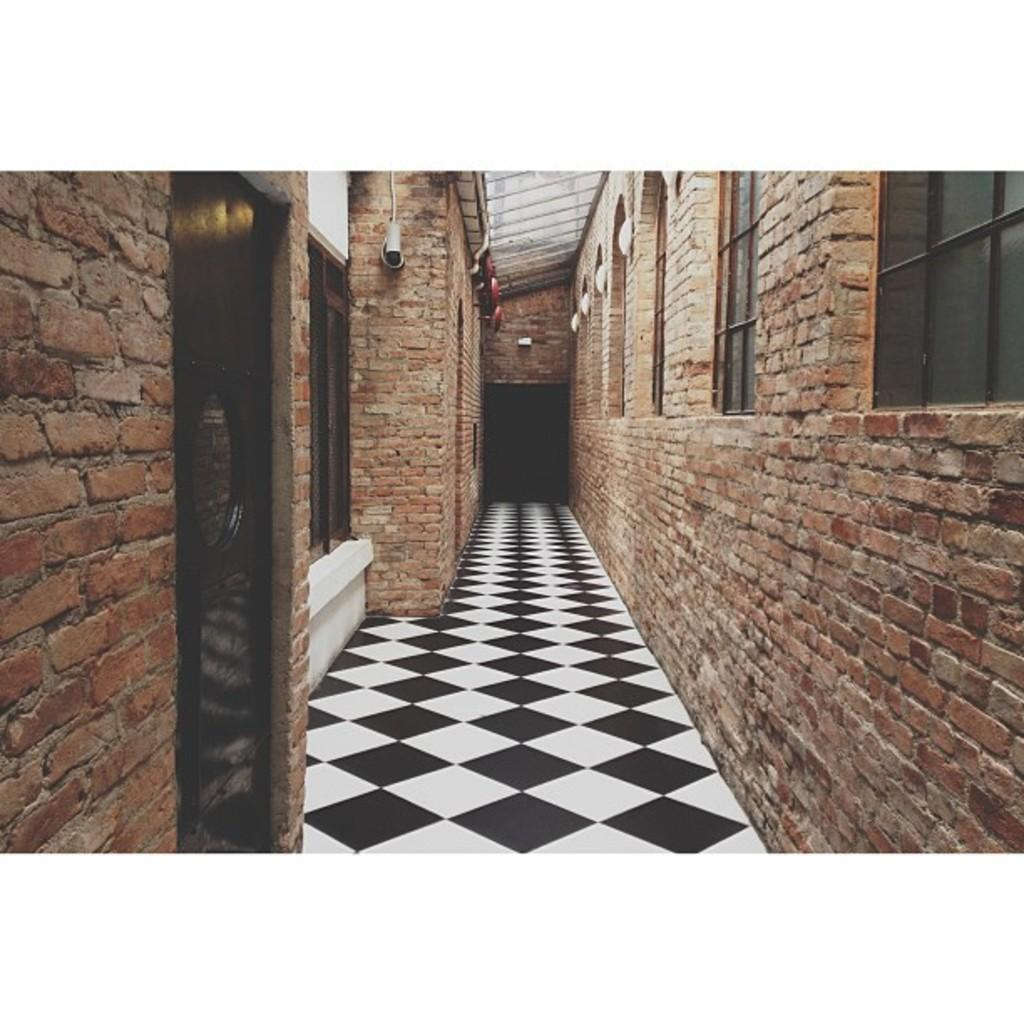What material is used to construct the walls in the image? The walls in the image are made of bricks. What type of opening can be seen in the walls? There is a door in the image. Are there any openings for light and ventilation in the walls? Yes, there are windows in the image. What is located at the top of the building in the image? There is a rooftop in the image. Where might this image have been taken? The image is likely taken in a building. What type of teeth can be seen on the rooftop in the image? There are no teeth visible on the rooftop in the image. 